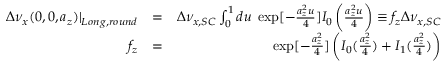<formula> <loc_0><loc_0><loc_500><loc_500>\begin{array} { r l r } { \Delta \nu _ { x } ( 0 , 0 , a _ { z } ) | _ { L o n g , r o u n d } } & { = } & { \Delta \nu _ { x , S C } \int _ { 0 } ^ { 1 } d u \, \exp [ - \frac { a _ { z } ^ { 2 } u } { 4 } ] I _ { 0 } \left ( \frac { a _ { z } ^ { 2 } u } { 4 } \right ) \equiv f _ { z } \Delta \nu _ { x , S C } } \\ { f _ { z } } & { = } & { \exp [ - \frac { a _ { z } ^ { 2 } } { 4 } ] \left ( I _ { 0 } ( \frac { a _ { z } ^ { 2 } } { 4 } ) + I _ { 1 } ( \frac { a _ { z } ^ { 2 } } { 4 } ) \right ) } \end{array}</formula> 